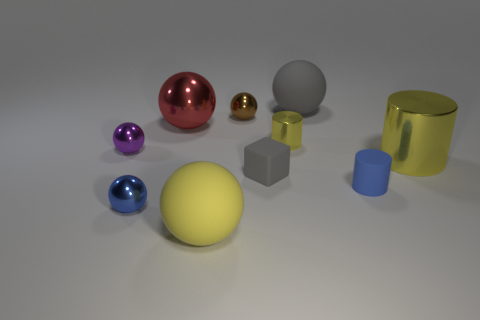Subtract all purple blocks. How many yellow cylinders are left? 2 Subtract all yellow rubber balls. How many balls are left? 5 Subtract all yellow balls. How many balls are left? 5 Subtract 2 balls. How many balls are left? 4 Subtract all blocks. How many objects are left? 9 Subtract all brown spheres. Subtract all yellow blocks. How many spheres are left? 5 Subtract all big metal objects. Subtract all gray objects. How many objects are left? 6 Add 7 big red things. How many big red things are left? 8 Add 4 large gray objects. How many large gray objects exist? 5 Subtract 0 gray cylinders. How many objects are left? 10 